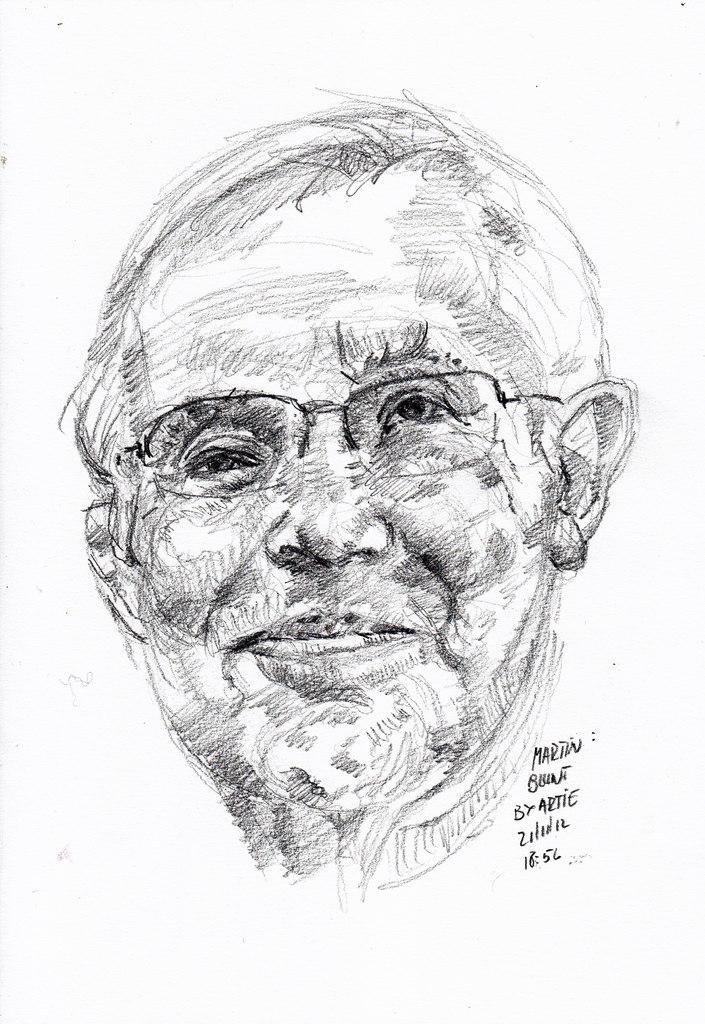In one or two sentences, can you explain what this image depicts? In this image we can see painting of a person who is wearing spectacles and there are some words written on it. 